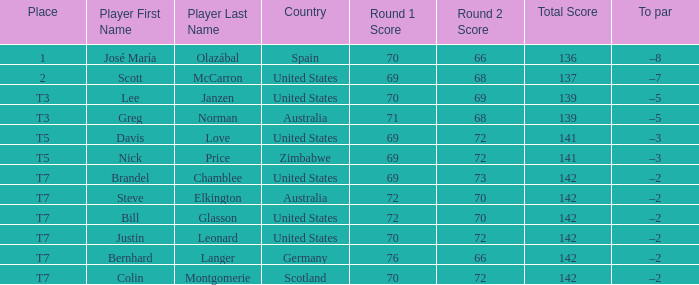Name the Player who has a To par of –2 and a Score of 69-73=142? Brandel Chamblee. 